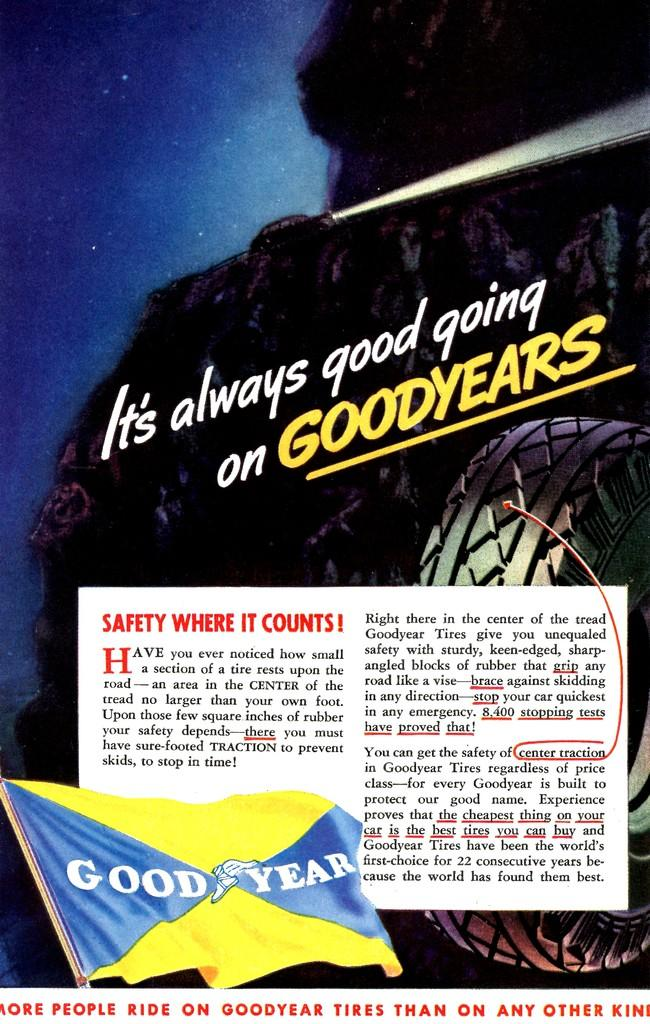What is featured on the poster in the image? There is a poster in the image that contains a flat object, a tire, a light, and text. Can you describe the flat object on the poster? The flat object on the poster is not specified, but it is part of the image on the poster. What type of object is the tire on the poster? The tire on the poster is a round object typically used on vehicles for support and traction. What is the purpose of the light on the poster? The purpose of the light on the poster is not specified, but it is part of the image on the poster. What type of information is conveyed by the text on the poster? The text on the poster conveys information related to the images on the poster, but the specific content is not mentioned. What type of meat is being cooked on the poster? There is no meat present on the poster; it contains a flat object, a tire, a light, and text. 